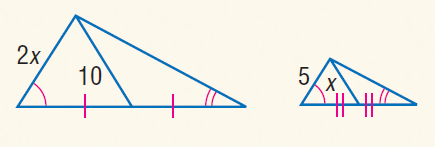Question: Find x.
Choices:
A. 5
B. 7.5
C. 10
D. 12.5
Answer with the letter. Answer: A 